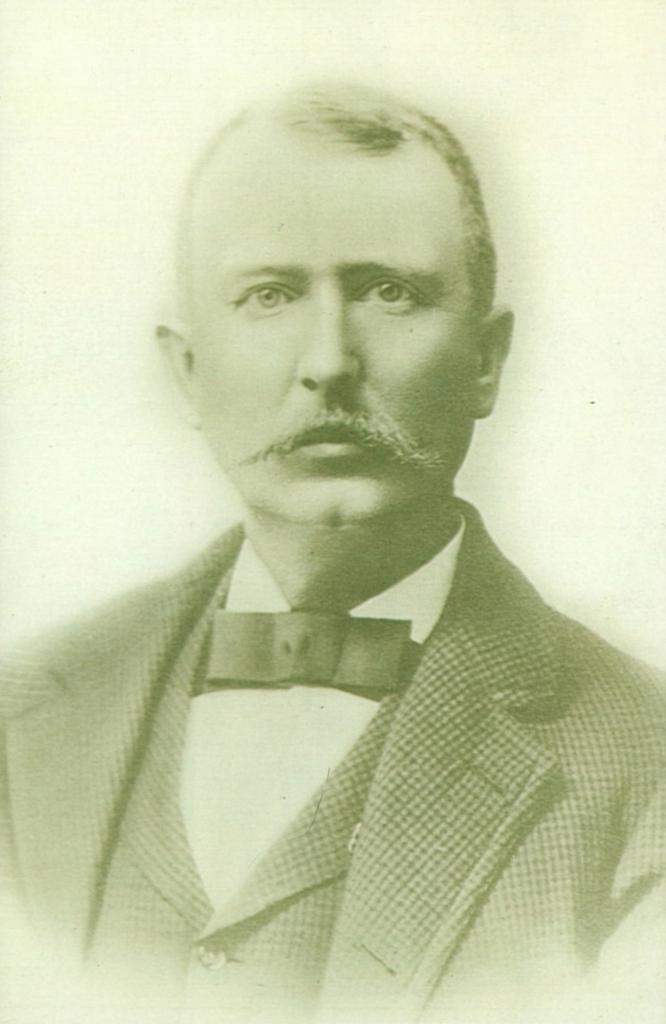What is the main subject of the image? The main subject of the image is a man. What is the man wearing in the image? The man is wearing a suit in the image. What type of plate is floating in space in the image? There is no plate or space present in the image; it features a man wearing a suit. What type of hospital is depicted in the image? There is no hospital depicted in the image; it features a man wearing a suit. 